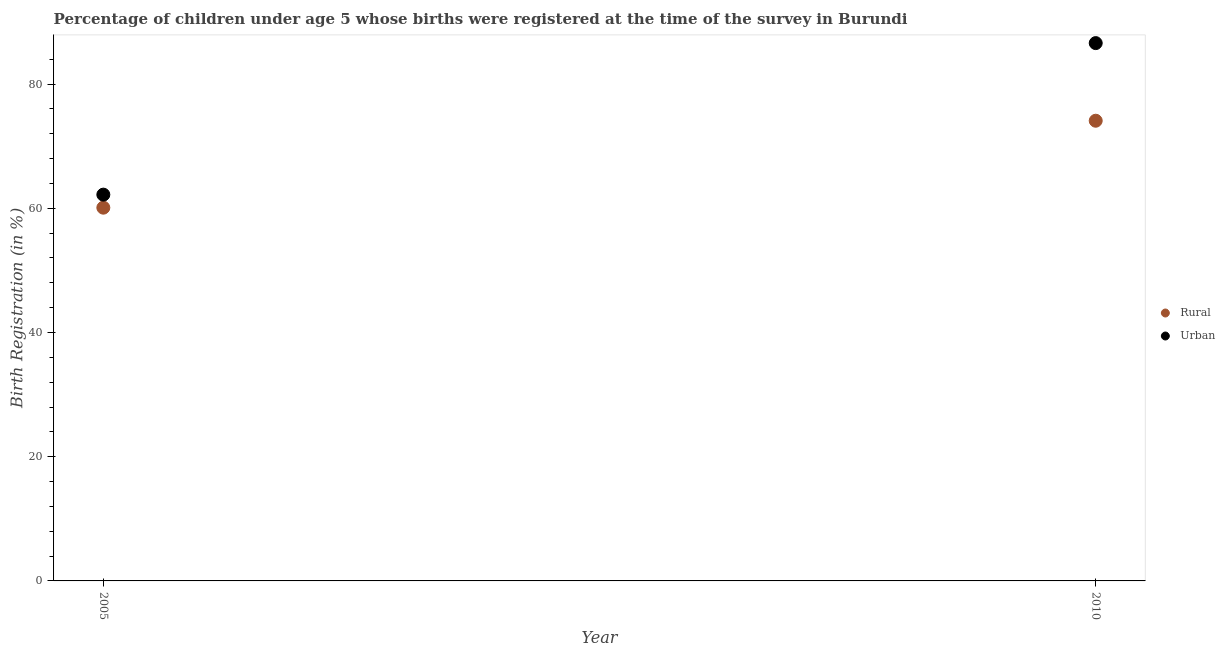How many different coloured dotlines are there?
Provide a succinct answer. 2. What is the rural birth registration in 2010?
Provide a succinct answer. 74.1. Across all years, what is the maximum urban birth registration?
Keep it short and to the point. 86.6. Across all years, what is the minimum rural birth registration?
Your answer should be compact. 60.1. In which year was the urban birth registration minimum?
Provide a succinct answer. 2005. What is the total rural birth registration in the graph?
Provide a succinct answer. 134.2. What is the difference between the urban birth registration in 2005 and that in 2010?
Your answer should be compact. -24.4. What is the difference between the rural birth registration in 2010 and the urban birth registration in 2005?
Make the answer very short. 11.9. What is the average rural birth registration per year?
Your answer should be compact. 67.1. In the year 2005, what is the difference between the rural birth registration and urban birth registration?
Offer a terse response. -2.1. What is the ratio of the rural birth registration in 2005 to that in 2010?
Offer a very short reply. 0.81. Does the rural birth registration monotonically increase over the years?
Offer a terse response. Yes. Is the urban birth registration strictly less than the rural birth registration over the years?
Your response must be concise. No. How many legend labels are there?
Your response must be concise. 2. How are the legend labels stacked?
Ensure brevity in your answer.  Vertical. What is the title of the graph?
Make the answer very short. Percentage of children under age 5 whose births were registered at the time of the survey in Burundi. What is the label or title of the Y-axis?
Your response must be concise. Birth Registration (in %). What is the Birth Registration (in %) of Rural in 2005?
Offer a very short reply. 60.1. What is the Birth Registration (in %) in Urban in 2005?
Offer a terse response. 62.2. What is the Birth Registration (in %) of Rural in 2010?
Offer a very short reply. 74.1. What is the Birth Registration (in %) in Urban in 2010?
Your response must be concise. 86.6. Across all years, what is the maximum Birth Registration (in %) of Rural?
Your response must be concise. 74.1. Across all years, what is the maximum Birth Registration (in %) of Urban?
Provide a short and direct response. 86.6. Across all years, what is the minimum Birth Registration (in %) in Rural?
Offer a terse response. 60.1. Across all years, what is the minimum Birth Registration (in %) of Urban?
Your response must be concise. 62.2. What is the total Birth Registration (in %) in Rural in the graph?
Offer a terse response. 134.2. What is the total Birth Registration (in %) in Urban in the graph?
Provide a succinct answer. 148.8. What is the difference between the Birth Registration (in %) of Urban in 2005 and that in 2010?
Provide a succinct answer. -24.4. What is the difference between the Birth Registration (in %) in Rural in 2005 and the Birth Registration (in %) in Urban in 2010?
Your answer should be very brief. -26.5. What is the average Birth Registration (in %) of Rural per year?
Your response must be concise. 67.1. What is the average Birth Registration (in %) in Urban per year?
Provide a succinct answer. 74.4. In the year 2010, what is the difference between the Birth Registration (in %) of Rural and Birth Registration (in %) of Urban?
Give a very brief answer. -12.5. What is the ratio of the Birth Registration (in %) of Rural in 2005 to that in 2010?
Your response must be concise. 0.81. What is the ratio of the Birth Registration (in %) of Urban in 2005 to that in 2010?
Make the answer very short. 0.72. What is the difference between the highest and the second highest Birth Registration (in %) of Rural?
Make the answer very short. 14. What is the difference between the highest and the second highest Birth Registration (in %) in Urban?
Your response must be concise. 24.4. What is the difference between the highest and the lowest Birth Registration (in %) in Rural?
Provide a short and direct response. 14. What is the difference between the highest and the lowest Birth Registration (in %) in Urban?
Provide a short and direct response. 24.4. 